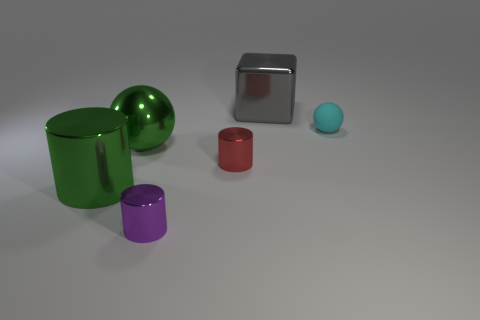What number of green things are in front of the sphere left of the big gray object?
Your answer should be compact. 1. There is a metallic object behind the metal ball; is its color the same as the metallic sphere?
Provide a short and direct response. No. How many objects are either tiny gray cubes or cyan spheres behind the small red metal object?
Offer a terse response. 1. There is a purple metal thing in front of the cyan rubber ball; is it the same shape as the big green metallic object behind the green cylinder?
Provide a short and direct response. No. Is there any other thing that has the same color as the rubber sphere?
Make the answer very short. No. There is a purple object that is made of the same material as the gray block; what is its shape?
Your answer should be compact. Cylinder. There is a thing that is left of the big gray block and to the right of the purple metallic cylinder; what is it made of?
Offer a terse response. Metal. Is there any other thing that is the same size as the green metal sphere?
Keep it short and to the point. Yes. Is the color of the matte ball the same as the big cylinder?
Your answer should be very brief. No. What is the shape of the big metallic object that is the same color as the big metallic sphere?
Your answer should be very brief. Cylinder. 